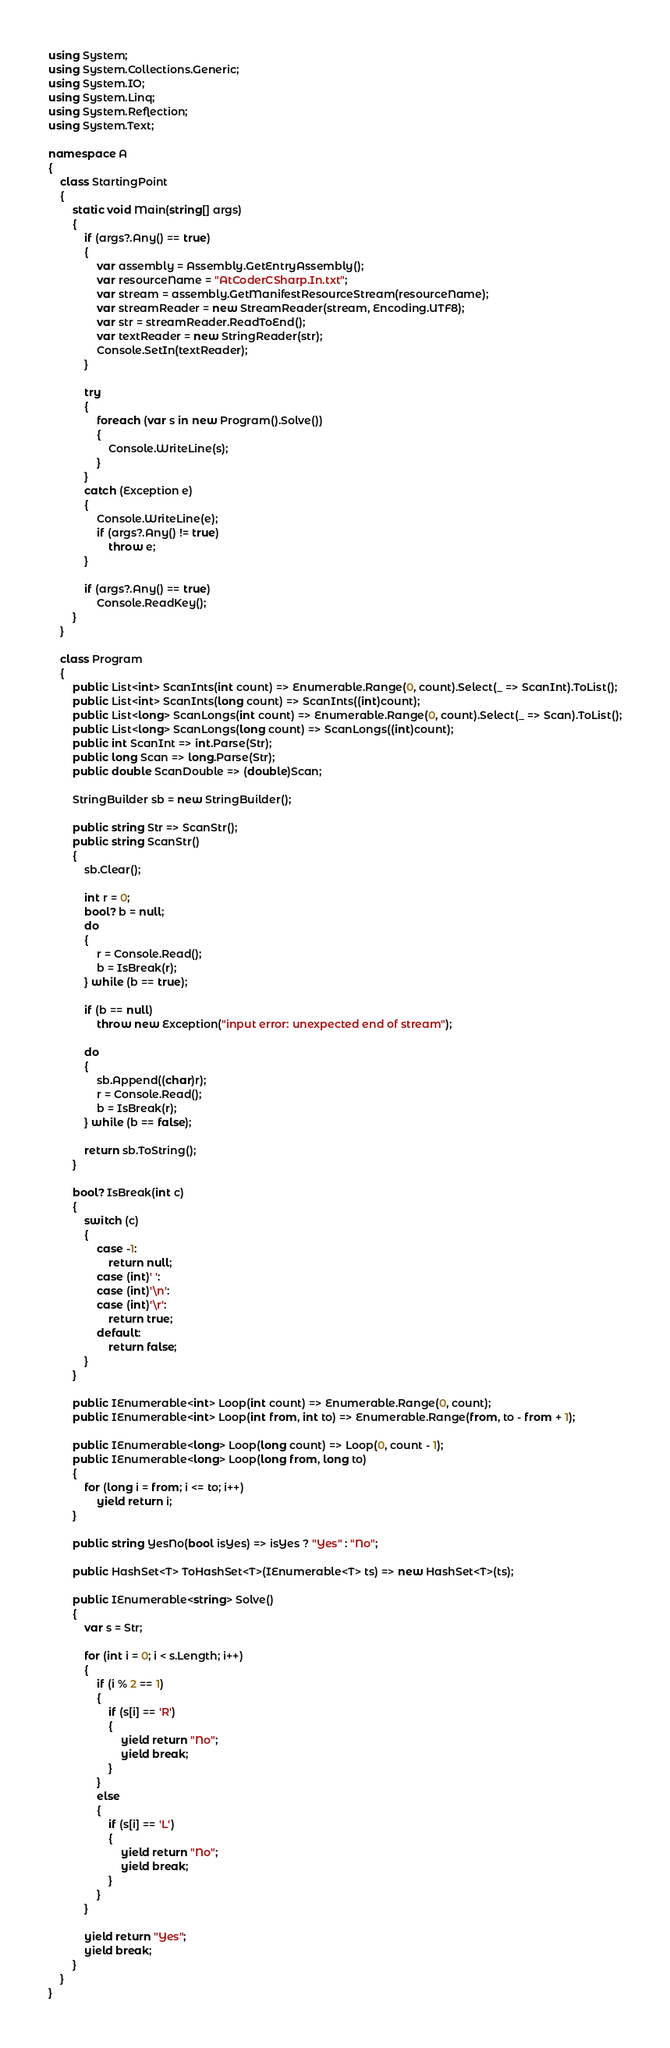<code> <loc_0><loc_0><loc_500><loc_500><_C#_>using System;
using System.Collections.Generic;
using System.IO;
using System.Linq;
using System.Reflection;
using System.Text;

namespace A
{
    class StartingPoint
    {
        static void Main(string[] args)
        {
            if (args?.Any() == true)
            {
                var assembly = Assembly.GetEntryAssembly();
                var resourceName = "AtCoderCSharp.In.txt";
                var stream = assembly.GetManifestResourceStream(resourceName);
                var streamReader = new StreamReader(stream, Encoding.UTF8);
                var str = streamReader.ReadToEnd();
                var textReader = new StringReader(str);
                Console.SetIn(textReader);
            }

            try
            {
                foreach (var s in new Program().Solve())
                {
                    Console.WriteLine(s);
                }
            }
            catch (Exception e)
            {
                Console.WriteLine(e);
                if (args?.Any() != true)
                    throw e;
            }

            if (args?.Any() == true)
                Console.ReadKey();
        }
    }

    class Program
    {
        public List<int> ScanInts(int count) => Enumerable.Range(0, count).Select(_ => ScanInt).ToList();
        public List<int> ScanInts(long count) => ScanInts((int)count);
        public List<long> ScanLongs(int count) => Enumerable.Range(0, count).Select(_ => Scan).ToList();
        public List<long> ScanLongs(long count) => ScanLongs((int)count);
        public int ScanInt => int.Parse(Str);
        public long Scan => long.Parse(Str);
        public double ScanDouble => (double)Scan;

        StringBuilder sb = new StringBuilder();

        public string Str => ScanStr();
        public string ScanStr()
        {
            sb.Clear();

            int r = 0;
            bool? b = null;
            do
            {
                r = Console.Read();
                b = IsBreak(r);
            } while (b == true);

            if (b == null)
                throw new Exception("input error: unexpected end of stream");

            do
            {
                sb.Append((char)r);
                r = Console.Read();
                b = IsBreak(r);
            } while (b == false);

            return sb.ToString();
        }

        bool? IsBreak(int c)
        {
            switch (c)
            {
                case -1:
                    return null;
                case (int)' ':
                case (int)'\n':
                case (int)'\r':
                    return true;
                default:
                    return false;
            }
        }

        public IEnumerable<int> Loop(int count) => Enumerable.Range(0, count);
        public IEnumerable<int> Loop(int from, int to) => Enumerable.Range(from, to - from + 1);

        public IEnumerable<long> Loop(long count) => Loop(0, count - 1);
        public IEnumerable<long> Loop(long from, long to)
        {
            for (long i = from; i <= to; i++)
                yield return i;
        }

        public string YesNo(bool isYes) => isYes ? "Yes" : "No";

        public HashSet<T> ToHashSet<T>(IEnumerable<T> ts) => new HashSet<T>(ts);

        public IEnumerable<string> Solve()
        {
            var s = Str;

            for (int i = 0; i < s.Length; i++)
            {
                if (i % 2 == 1)
                {
                    if (s[i] == 'R')
                    {
                        yield return "No";
                        yield break;
                    }
                }
                else
                {
                    if (s[i] == 'L')
                    {
                        yield return "No";
                        yield break;
                    }
                }
            }

            yield return "Yes";
            yield break;
        }
    }
}</code> 